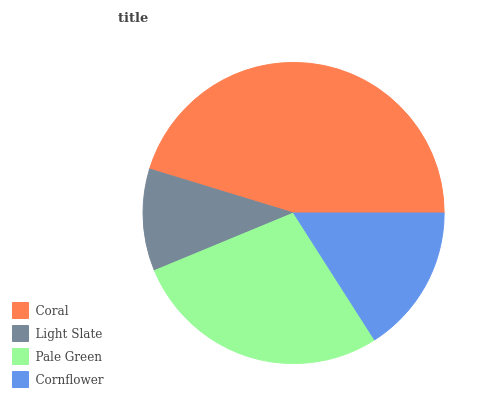Is Light Slate the minimum?
Answer yes or no. Yes. Is Coral the maximum?
Answer yes or no. Yes. Is Pale Green the minimum?
Answer yes or no. No. Is Pale Green the maximum?
Answer yes or no. No. Is Pale Green greater than Light Slate?
Answer yes or no. Yes. Is Light Slate less than Pale Green?
Answer yes or no. Yes. Is Light Slate greater than Pale Green?
Answer yes or no. No. Is Pale Green less than Light Slate?
Answer yes or no. No. Is Pale Green the high median?
Answer yes or no. Yes. Is Cornflower the low median?
Answer yes or no. Yes. Is Light Slate the high median?
Answer yes or no. No. Is Coral the low median?
Answer yes or no. No. 